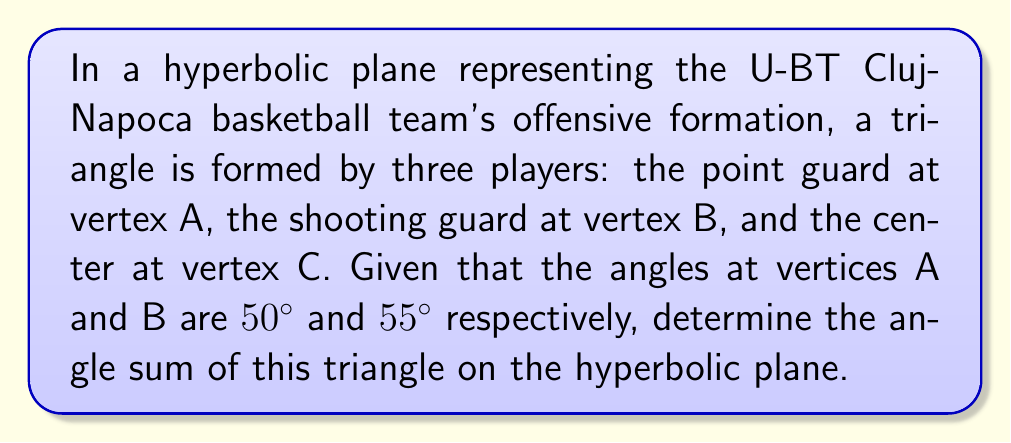Can you answer this question? To solve this problem, we need to follow these steps:

1) Recall that in hyperbolic geometry, the angle sum of a triangle is always less than $180°$ (or $\pi$ radians).

2) In Euclidean geometry, we would expect the third angle to be $180° - (50° + 55°) = 75°$. However, this is not the case in hyperbolic geometry.

3) Let's denote the angle at vertex C as $\theta$. We know that in hyperbolic geometry:

   $$\angle A + \angle B + \angle C < 180°$$

4) Substituting the known values:

   $$50° + 55° + \theta < 180°$$
   $$105° + \theta < 180°$$

5) We can't determine the exact value of $\theta$, but we know it must be less than $75°$.

6) To find the angle sum, we add all three angles:

   $$\text{Angle Sum} = 50° + 55° + \theta = 105° + \theta$$

7) Since $\theta < 75°$, we can conclude that the angle sum must be less than $180°$ but greater than $105°$.

8) The exact angle sum depends on the specific curvature of the hyperbolic plane, which is not given in the problem. However, we can state with certainty that it is less than $180°$.
Answer: Less than $180°$ 